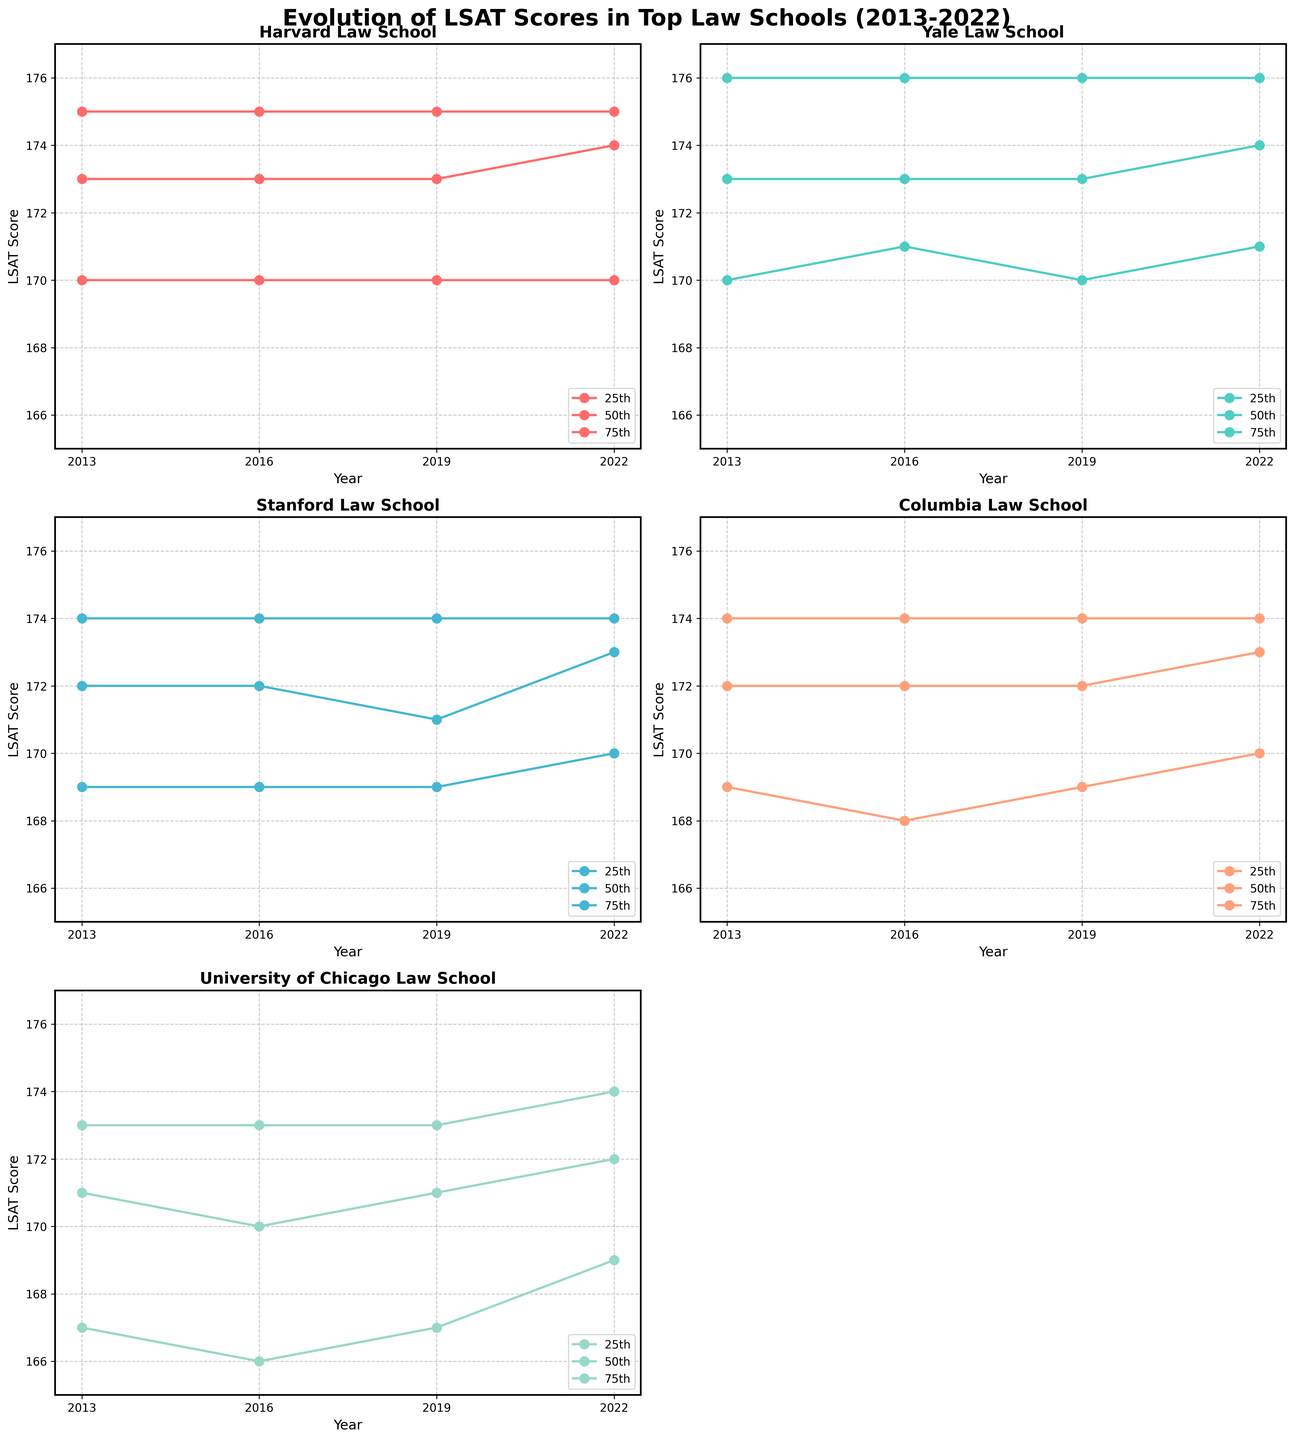What is the highest 75th percentile LSAT score observed across all schools and years? To find this, look for the maximum value in the 75th percentile lines for all schools across all years. The highest 75th percentile score appears for Yale Law School in 2013, 2016, 2019, and 2022, which is 176.
Answer: 176 How does the 25th percentile LSAT score for Harvard Law School in 2022 compare to its 25th percentile score in 2013? Compare the 25th percentile score for Harvard Law School in 2022 (170) with its score in 2013 (170). Both are the same.
Answer: The same Which school shows a decrease in their 25th percentile LSAT score from 2013 to 2016? Identify the schools and compare their 25th percentile scores in 2013 and 2016. University of Chicago Law School shows a decrease from 167 in 2013 to 166 in 2016.
Answer: University of Chicago Law School Which school's median LSAT score remained constant across all years? Review the 50th percentile lines for each school and observe which one remains unchanged from 2013 to 2022. Harvard Law School shows a constant median LSAT score of 173 across all years.
Answer: Harvard Law School What trend can be observed in the 75th percentile LSAT scores of Stanford Law School from 2013 to 2022? Look at the 75th percentile line for Stanford Law School. The scores remain constant at 174 from 2013 to 2022.
Answer: Constant trend By how much did the median LSAT score for Columbia Law School change from 2013 to 2022? Subtract the median score for 2013 (172) from the median score for 2022 (173), resulting in an increase of 1 point.
Answer: Increased by 1 point Which percentile saw an increase for Yale Law School from 2013 to 2022? Compare all percentiles for Yale Law School from 2013 to 2022. Only the 25th percentile increased from 170 to 171, and the 50th percentile increased from 173 to 174.
Answer: 25th and 50th percentiles Which school's 25th percentile LSAT score remained most stable over the decade? Review the 25th percentile lines for each school to see which has the least variation. Harvard Law School’s 25th percentile score remains stable at 170 throughout the years.
Answer: Harvard Law School 